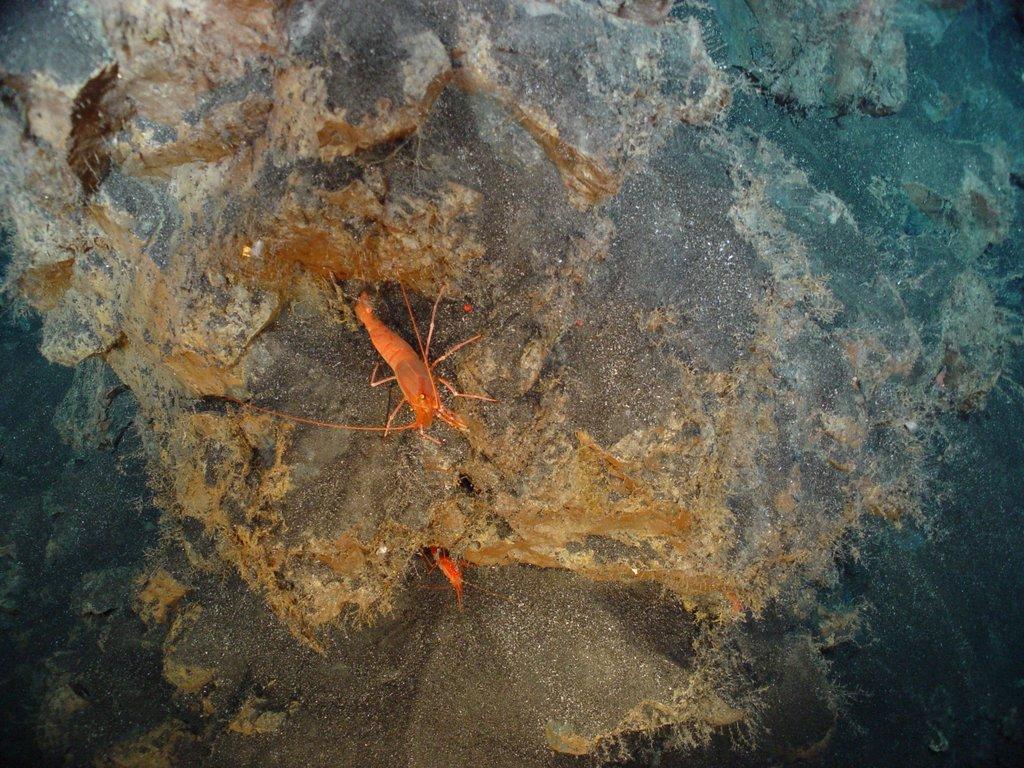In one or two sentences, can you explain what this image depicts? This image consists of a rock. On which there are two insects in orange color. 